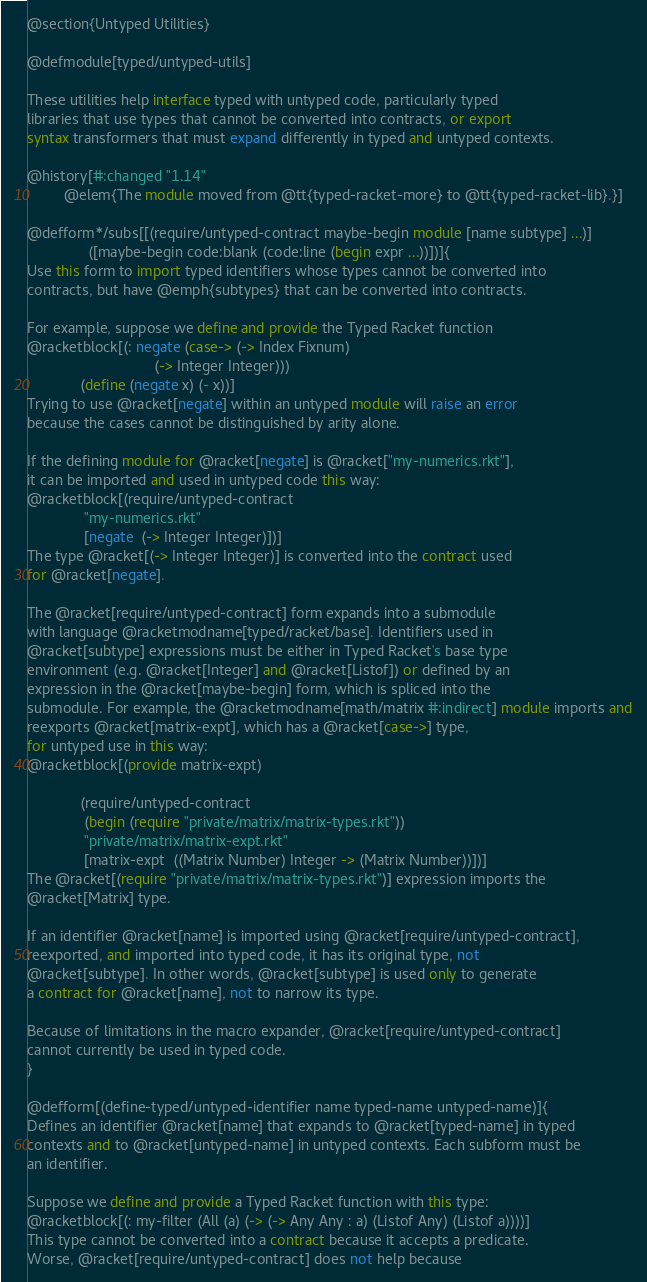Convert code to text. <code><loc_0><loc_0><loc_500><loc_500><_Racket_>

@section{Untyped Utilities}

@defmodule[typed/untyped-utils]

These utilities help interface typed with untyped code, particularly typed
libraries that use types that cannot be converted into contracts, or export
syntax transformers that must expand differently in typed and untyped contexts.

@history[#:changed "1.14"
         @elem{The module moved from @tt{typed-racket-more} to @tt{typed-racket-lib}.}]

@defform*/subs[[(require/untyped-contract maybe-begin module [name subtype] ...)]
               ([maybe-begin code:blank (code:line (begin expr ...))])]{
Use this form to import typed identifiers whose types cannot be converted into
contracts, but have @emph{subtypes} that can be converted into contracts.

For example, suppose we define and provide the Typed Racket function
@racketblock[(: negate (case-> (-> Index Fixnum)
                               (-> Integer Integer)))
             (define (negate x) (- x))]
Trying to use @racket[negate] within an untyped module will raise an error
because the cases cannot be distinguished by arity alone.

If the defining module for @racket[negate] is @racket["my-numerics.rkt"],
it can be imported and used in untyped code this way:
@racketblock[(require/untyped-contract
              "my-numerics.rkt"
              [negate  (-> Integer Integer)])]
The type @racket[(-> Integer Integer)] is converted into the contract used
for @racket[negate].

The @racket[require/untyped-contract] form expands into a submodule
with language @racketmodname[typed/racket/base]. Identifiers used in
@racket[subtype] expressions must be either in Typed Racket's base type
environment (e.g. @racket[Integer] and @racket[Listof]) or defined by an
expression in the @racket[maybe-begin] form, which is spliced into the
submodule. For example, the @racketmodname[math/matrix #:indirect] module imports and
reexports @racket[matrix-expt], which has a @racket[case->] type,
for untyped use in this way:
@racketblock[(provide matrix-expt)
             
             (require/untyped-contract
              (begin (require "private/matrix/matrix-types.rkt"))
              "private/matrix/matrix-expt.rkt"
              [matrix-expt  ((Matrix Number) Integer -> (Matrix Number))])]
The @racket[(require "private/matrix/matrix-types.rkt")] expression imports the
@racket[Matrix] type.

If an identifier @racket[name] is imported using @racket[require/untyped-contract],
reexported, and imported into typed code, it has its original type, not
@racket[subtype]. In other words, @racket[subtype] is used only to generate
a contract for @racket[name], not to narrow its type.

Because of limitations in the macro expander, @racket[require/untyped-contract]
cannot currently be used in typed code.
}

@defform[(define-typed/untyped-identifier name typed-name untyped-name)]{
Defines an identifier @racket[name] that expands to @racket[typed-name] in typed
contexts and to @racket[untyped-name] in untyped contexts. Each subform must be
an identifier.

Suppose we define and provide a Typed Racket function with this type:
@racketblock[(: my-filter (All (a) (-> (-> Any Any : a) (Listof Any) (Listof a))))]
This type cannot be converted into a contract because it accepts a predicate.
Worse, @racket[require/untyped-contract] does not help because</code> 